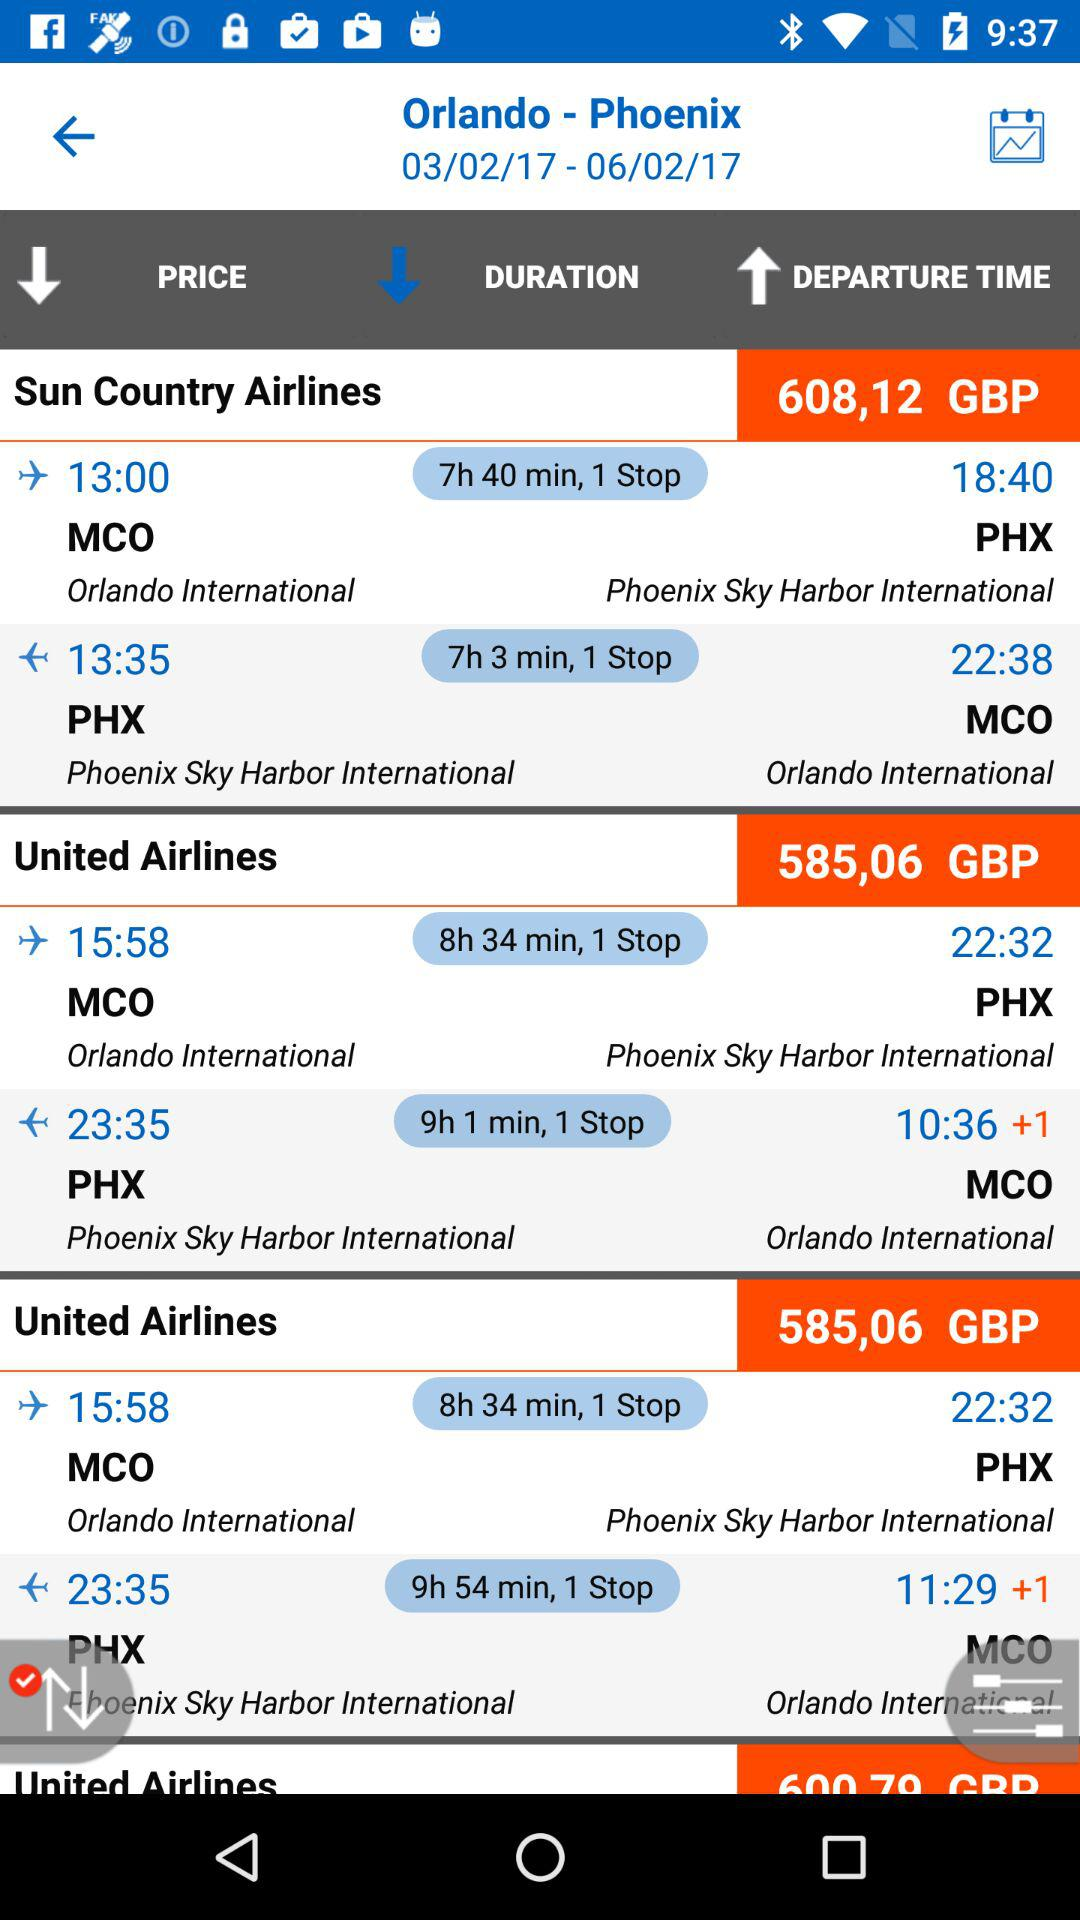For which date is the flight from Orlando to Phoenix being searched? The flight is being searched for March 2, 2017. 